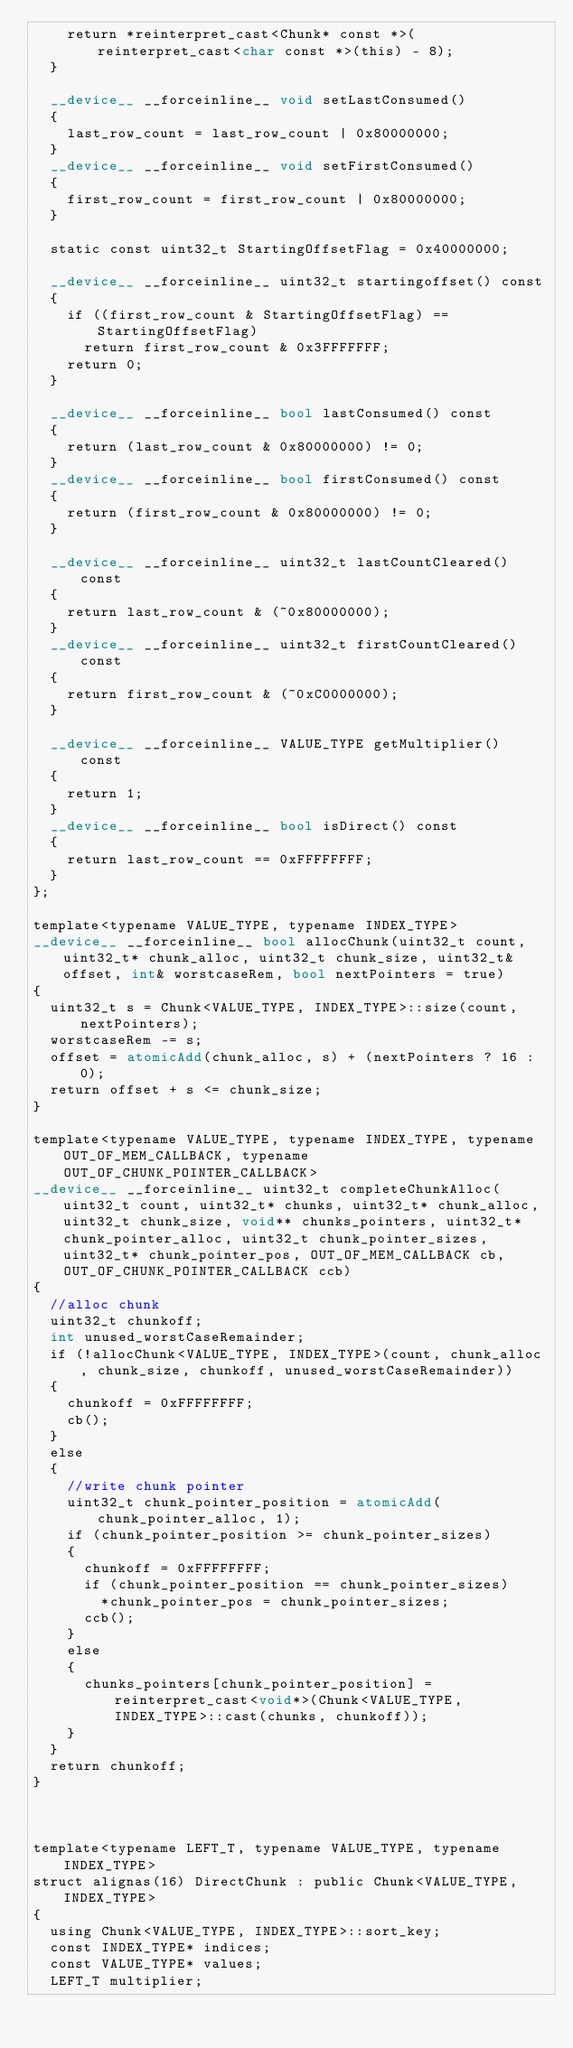<code> <loc_0><loc_0><loc_500><loc_500><_Cuda_>		return *reinterpret_cast<Chunk* const *>(reinterpret_cast<char const *>(this) - 8);
	}

	__device__ __forceinline__ void setLastConsumed()
	{
		last_row_count = last_row_count | 0x80000000;
	}
	__device__ __forceinline__ void setFirstConsumed()
	{
		first_row_count = first_row_count | 0x80000000;
	}

	static const uint32_t StartingOffsetFlag = 0x40000000;

	__device__ __forceinline__ uint32_t startingoffset() const
	{
		if ((first_row_count & StartingOffsetFlag) == StartingOffsetFlag)
			return first_row_count & 0x3FFFFFFF;
		return 0;
	}

	__device__ __forceinline__ bool lastConsumed() const
	{
		return (last_row_count & 0x80000000) != 0;
	}
	__device__ __forceinline__ bool firstConsumed() const
	{
		return (first_row_count & 0x80000000) != 0;
	}

	__device__ __forceinline__ uint32_t lastCountCleared() const
	{
		return last_row_count & (~0x80000000);
	}
	__device__ __forceinline__ uint32_t firstCountCleared() const
	{
		return first_row_count & (~0xC0000000);
	}

	__device__ __forceinline__ VALUE_TYPE getMultiplier() const
	{
		return 1;
	}
	__device__ __forceinline__ bool isDirect() const
	{
		return last_row_count == 0xFFFFFFFF;
	}
};

template<typename VALUE_TYPE, typename INDEX_TYPE>
__device__ __forceinline__ bool allocChunk(uint32_t count, uint32_t* chunk_alloc, uint32_t chunk_size, uint32_t& offset, int& worstcaseRem, bool nextPointers = true)
{
	uint32_t s = Chunk<VALUE_TYPE, INDEX_TYPE>::size(count, nextPointers);
	worstcaseRem -= s;
	offset = atomicAdd(chunk_alloc, s) + (nextPointers ? 16 : 0);
	return offset + s <= chunk_size;
}

template<typename VALUE_TYPE, typename INDEX_TYPE, typename OUT_OF_MEM_CALLBACK, typename OUT_OF_CHUNK_POINTER_CALLBACK>
__device__ __forceinline__ uint32_t completeChunkAlloc(uint32_t count, uint32_t* chunks, uint32_t* chunk_alloc, uint32_t chunk_size, void** chunks_pointers, uint32_t* chunk_pointer_alloc, uint32_t chunk_pointer_sizes, uint32_t* chunk_pointer_pos, OUT_OF_MEM_CALLBACK cb, OUT_OF_CHUNK_POINTER_CALLBACK ccb)
{
	//alloc chunk
	uint32_t chunkoff;
	int unused_worstCaseRemainder;
	if (!allocChunk<VALUE_TYPE, INDEX_TYPE>(count, chunk_alloc, chunk_size, chunkoff, unused_worstCaseRemainder))
	{
		chunkoff = 0xFFFFFFFF;
		cb();
	}
	else
	{
		//write chunk pointer
		uint32_t chunk_pointer_position = atomicAdd(chunk_pointer_alloc, 1);
		if (chunk_pointer_position >= chunk_pointer_sizes)
		{
			chunkoff = 0xFFFFFFFF;
			if (chunk_pointer_position == chunk_pointer_sizes)
				*chunk_pointer_pos = chunk_pointer_sizes;
			ccb();
		}
		else
		{
			chunks_pointers[chunk_pointer_position] = reinterpret_cast<void*>(Chunk<VALUE_TYPE, INDEX_TYPE>::cast(chunks, chunkoff));
		}		
	}
	return chunkoff;
}



template<typename LEFT_T, typename VALUE_TYPE, typename INDEX_TYPE>
struct alignas(16) DirectChunk : public Chunk<VALUE_TYPE, INDEX_TYPE>
{
	using Chunk<VALUE_TYPE, INDEX_TYPE>::sort_key;
	const INDEX_TYPE* indices;
	const VALUE_TYPE* values;
	LEFT_T multiplier;
</code> 